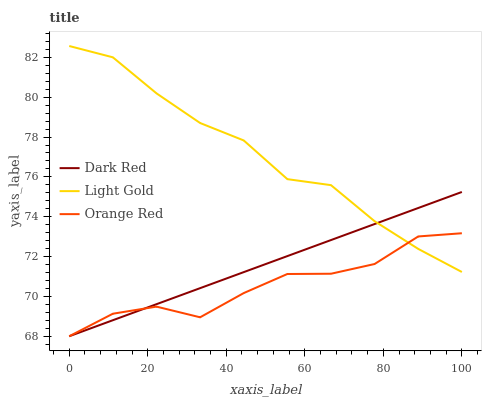Does Orange Red have the minimum area under the curve?
Answer yes or no. Yes. Does Light Gold have the maximum area under the curve?
Answer yes or no. Yes. Does Light Gold have the minimum area under the curve?
Answer yes or no. No. Does Orange Red have the maximum area under the curve?
Answer yes or no. No. Is Dark Red the smoothest?
Answer yes or no. Yes. Is Orange Red the roughest?
Answer yes or no. Yes. Is Light Gold the smoothest?
Answer yes or no. No. Is Light Gold the roughest?
Answer yes or no. No. Does Dark Red have the lowest value?
Answer yes or no. Yes. Does Light Gold have the lowest value?
Answer yes or no. No. Does Light Gold have the highest value?
Answer yes or no. Yes. Does Orange Red have the highest value?
Answer yes or no. No. Does Orange Red intersect Dark Red?
Answer yes or no. Yes. Is Orange Red less than Dark Red?
Answer yes or no. No. Is Orange Red greater than Dark Red?
Answer yes or no. No. 